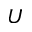<formula> <loc_0><loc_0><loc_500><loc_500>U</formula> 